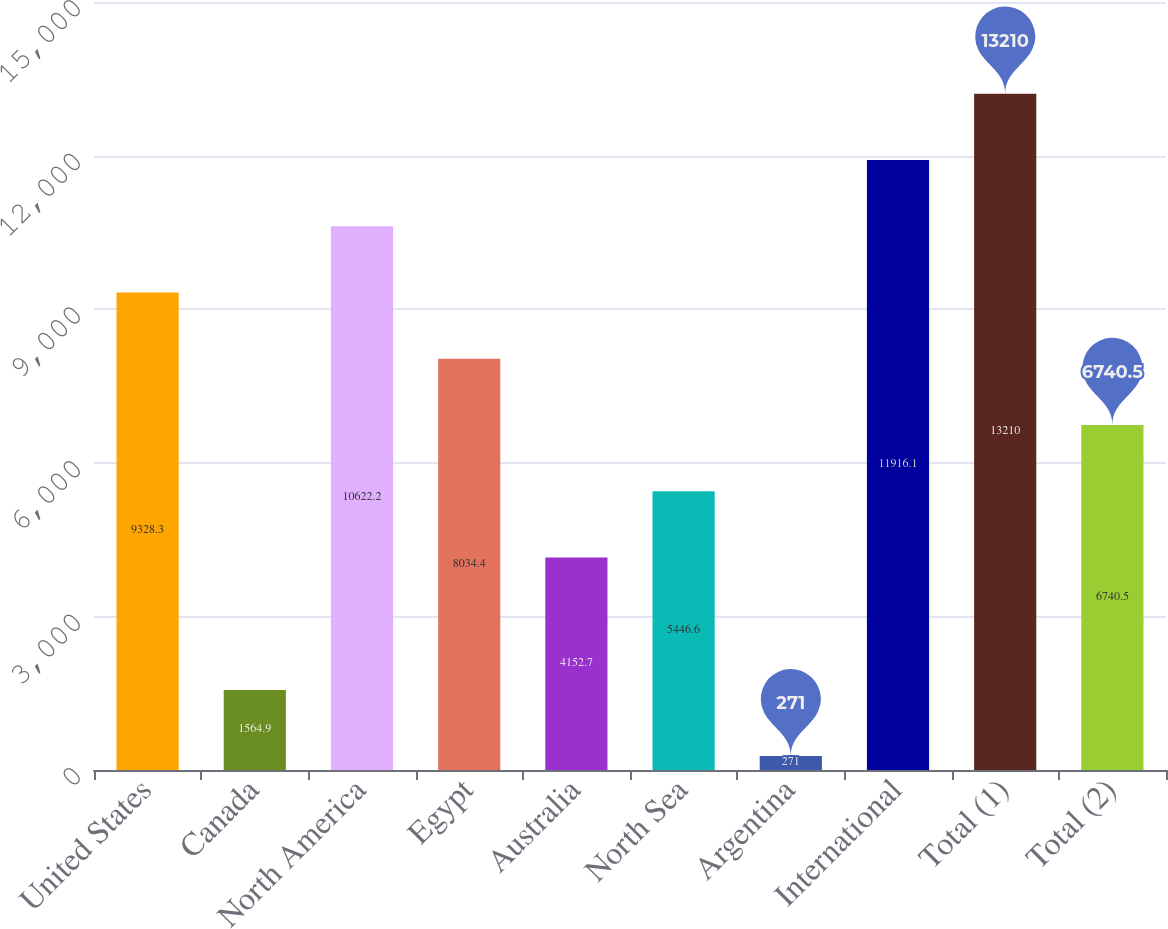Convert chart to OTSL. <chart><loc_0><loc_0><loc_500><loc_500><bar_chart><fcel>United States<fcel>Canada<fcel>North America<fcel>Egypt<fcel>Australia<fcel>North Sea<fcel>Argentina<fcel>International<fcel>Total (1)<fcel>Total (2)<nl><fcel>9328.3<fcel>1564.9<fcel>10622.2<fcel>8034.4<fcel>4152.7<fcel>5446.6<fcel>271<fcel>11916.1<fcel>13210<fcel>6740.5<nl></chart> 